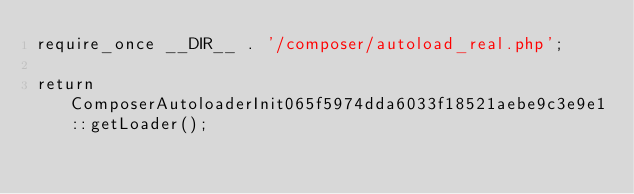Convert code to text. <code><loc_0><loc_0><loc_500><loc_500><_PHP_>require_once __DIR__ . '/composer/autoload_real.php';

return ComposerAutoloaderInit065f5974dda6033f18521aebe9c3e9e1::getLoader();
</code> 